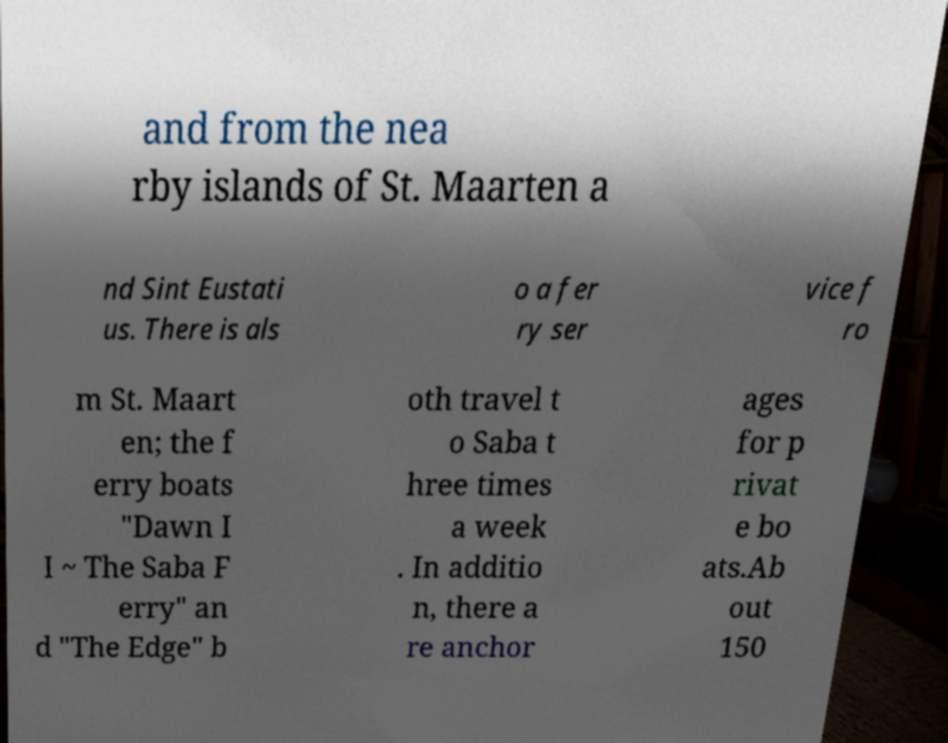Can you accurately transcribe the text from the provided image for me? and from the nea rby islands of St. Maarten a nd Sint Eustati us. There is als o a fer ry ser vice f ro m St. Maart en; the f erry boats "Dawn I I ~ The Saba F erry" an d "The Edge" b oth travel t o Saba t hree times a week . In additio n, there a re anchor ages for p rivat e bo ats.Ab out 150 